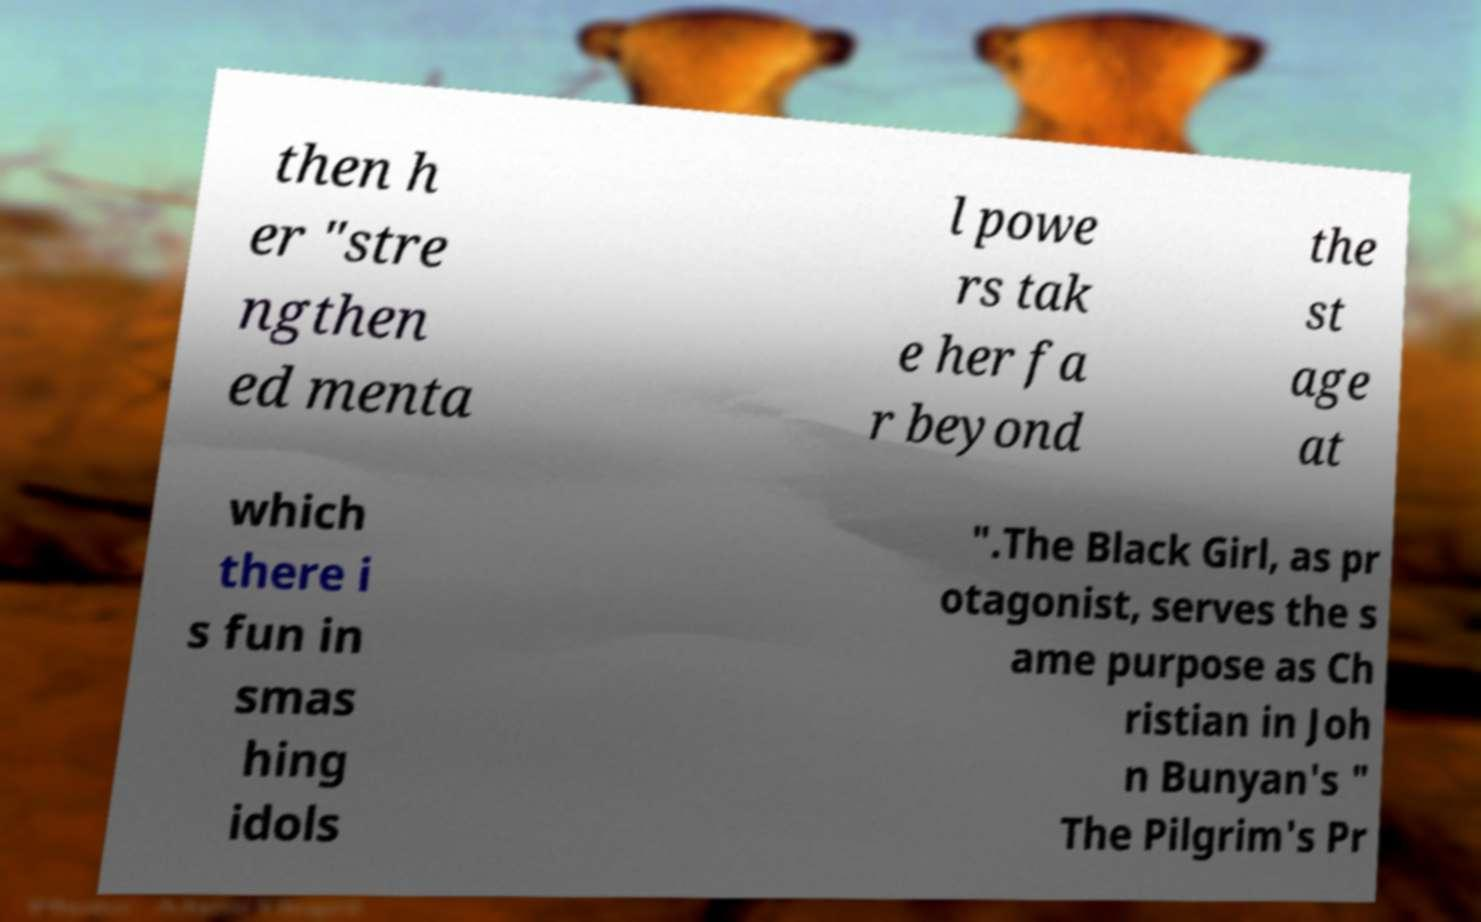I need the written content from this picture converted into text. Can you do that? then h er "stre ngthen ed menta l powe rs tak e her fa r beyond the st age at which there i s fun in smas hing idols ".The Black Girl, as pr otagonist, serves the s ame purpose as Ch ristian in Joh n Bunyan's " The Pilgrim's Pr 